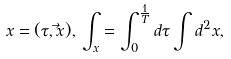<formula> <loc_0><loc_0><loc_500><loc_500>x = ( \tau , \vec { x } ) , \, \int _ { x } = \int _ { 0 } ^ { \frac { 1 } { T } } d \tau \int d ^ { 2 } x ,</formula> 